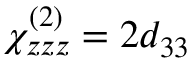<formula> <loc_0><loc_0><loc_500><loc_500>\chi _ { z z z } ^ { ( 2 ) } = 2 d _ { 3 3 }</formula> 